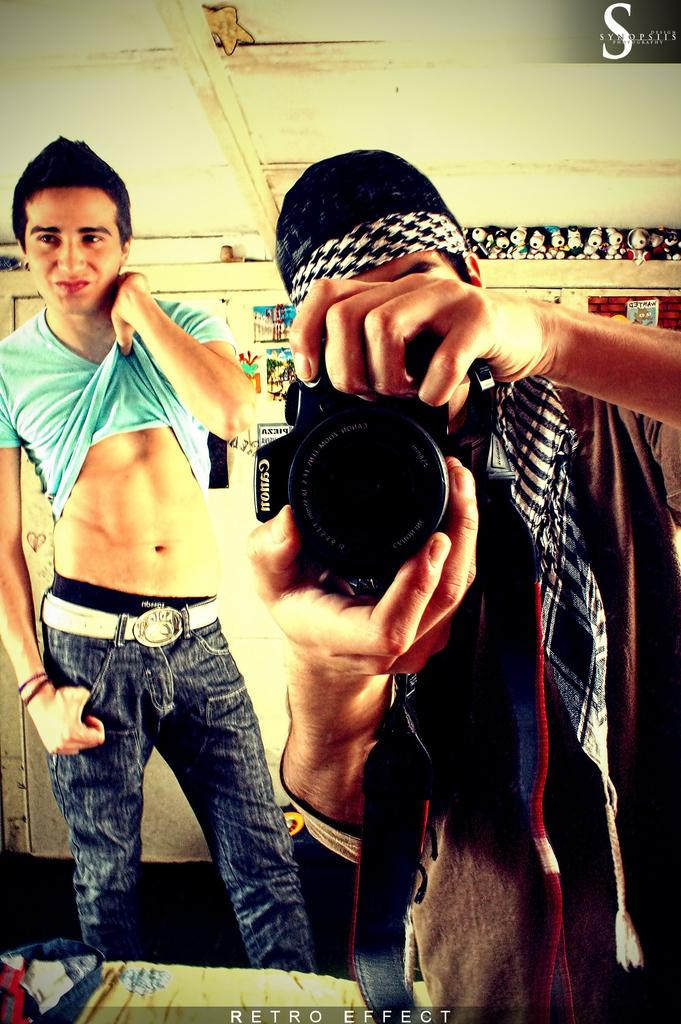What is the man in the image wearing around his neck? The man is wearing a scarf in the image. What is the man holding in the image? The man is holding a camera in the image. How is the other man in the image expressing himself? The other man is giving a smile and standing still in the image. What type of objects can be seen in the image besides the people? There are toys in the image. What can be seen on the wall in the image? There is a poster on a wall in the image. How many ducks are visible in the image? There are no ducks present in the image. What type of coat is the man wearing in the image? The man is not wearing a coat in the image; he is wearing a scarf. 